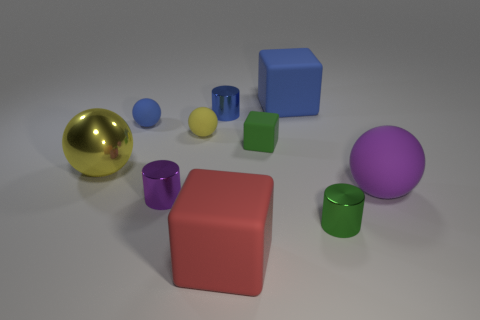Subtract all balls. How many objects are left? 6 Subtract all tiny green matte spheres. Subtract all metal cylinders. How many objects are left? 7 Add 1 tiny green metal cylinders. How many tiny green metal cylinders are left? 2 Add 9 small cyan metallic cylinders. How many small cyan metallic cylinders exist? 9 Subtract 0 yellow cylinders. How many objects are left? 10 